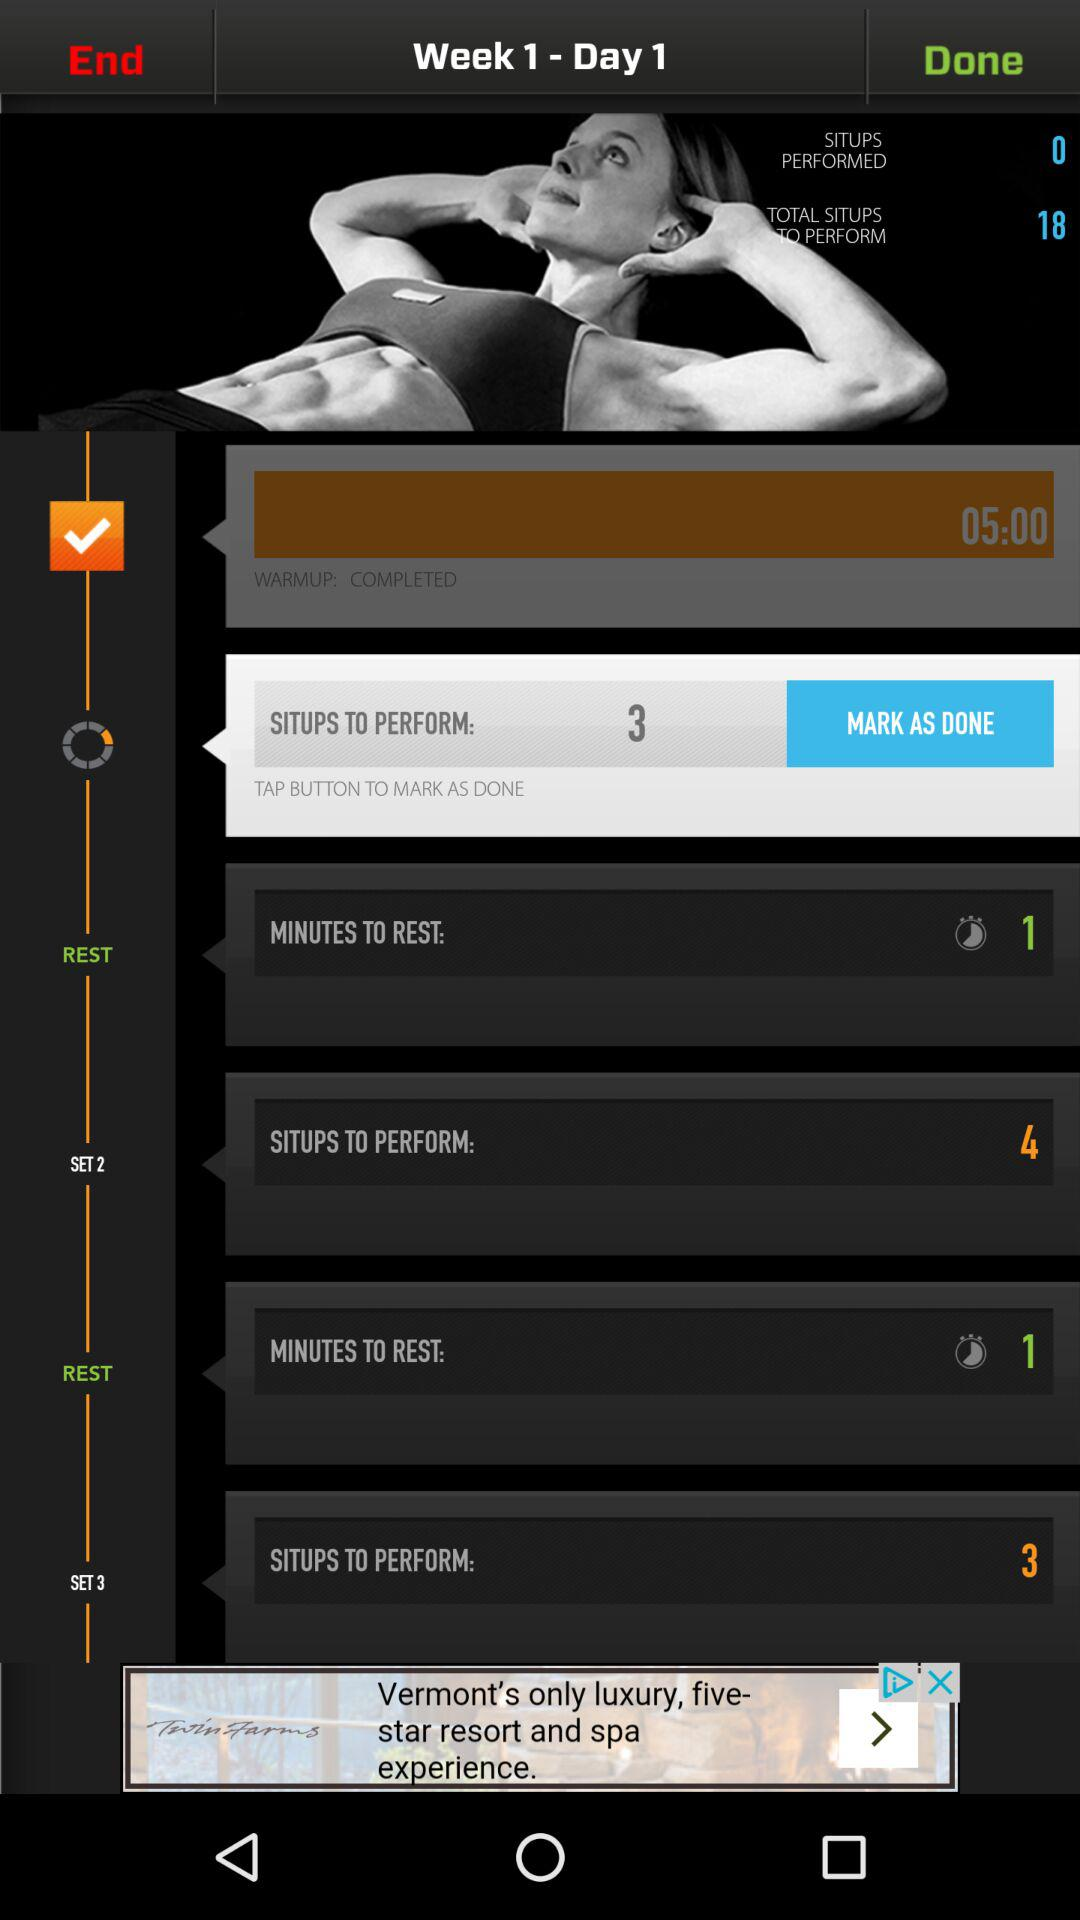What is the number of situps to perform in set 2? The number of situps to perform in set 2 is 4. 